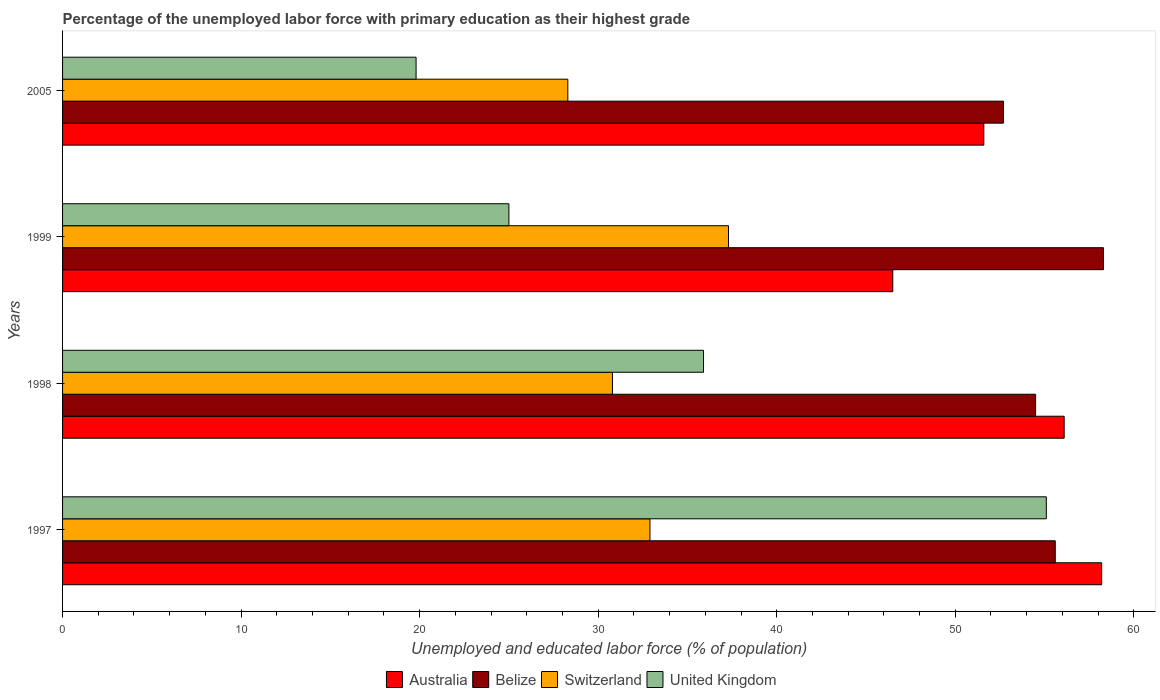How many different coloured bars are there?
Give a very brief answer. 4. How many groups of bars are there?
Your answer should be very brief. 4. Are the number of bars per tick equal to the number of legend labels?
Offer a very short reply. Yes. Are the number of bars on each tick of the Y-axis equal?
Ensure brevity in your answer.  Yes. How many bars are there on the 2nd tick from the bottom?
Offer a very short reply. 4. What is the percentage of the unemployed labor force with primary education in Belize in 1998?
Your answer should be very brief. 54.5. Across all years, what is the maximum percentage of the unemployed labor force with primary education in United Kingdom?
Ensure brevity in your answer.  55.1. Across all years, what is the minimum percentage of the unemployed labor force with primary education in Australia?
Keep it short and to the point. 46.5. In which year was the percentage of the unemployed labor force with primary education in United Kingdom maximum?
Keep it short and to the point. 1997. What is the total percentage of the unemployed labor force with primary education in Switzerland in the graph?
Make the answer very short. 129.3. What is the difference between the percentage of the unemployed labor force with primary education in Belize in 1997 and that in 2005?
Provide a succinct answer. 2.9. What is the difference between the percentage of the unemployed labor force with primary education in Belize in 1998 and the percentage of the unemployed labor force with primary education in United Kingdom in 1999?
Keep it short and to the point. 29.5. What is the average percentage of the unemployed labor force with primary education in Australia per year?
Make the answer very short. 53.1. In the year 1997, what is the difference between the percentage of the unemployed labor force with primary education in United Kingdom and percentage of the unemployed labor force with primary education in Belize?
Your answer should be very brief. -0.5. What is the ratio of the percentage of the unemployed labor force with primary education in Switzerland in 1998 to that in 1999?
Your answer should be very brief. 0.83. What is the difference between the highest and the second highest percentage of the unemployed labor force with primary education in Belize?
Keep it short and to the point. 2.7. What is the difference between the highest and the lowest percentage of the unemployed labor force with primary education in Belize?
Your answer should be compact. 5.6. Is the sum of the percentage of the unemployed labor force with primary education in Switzerland in 1999 and 2005 greater than the maximum percentage of the unemployed labor force with primary education in Australia across all years?
Offer a very short reply. Yes. Is it the case that in every year, the sum of the percentage of the unemployed labor force with primary education in United Kingdom and percentage of the unemployed labor force with primary education in Australia is greater than the sum of percentage of the unemployed labor force with primary education in Belize and percentage of the unemployed labor force with primary education in Switzerland?
Your answer should be compact. No. What does the 2nd bar from the top in 1999 represents?
Your answer should be compact. Switzerland. How many bars are there?
Offer a terse response. 16. Are all the bars in the graph horizontal?
Offer a terse response. Yes. How many years are there in the graph?
Your answer should be compact. 4. Are the values on the major ticks of X-axis written in scientific E-notation?
Your answer should be compact. No. What is the title of the graph?
Ensure brevity in your answer.  Percentage of the unemployed labor force with primary education as their highest grade. Does "Channel Islands" appear as one of the legend labels in the graph?
Your response must be concise. No. What is the label or title of the X-axis?
Provide a short and direct response. Unemployed and educated labor force (% of population). What is the Unemployed and educated labor force (% of population) in Australia in 1997?
Your response must be concise. 58.2. What is the Unemployed and educated labor force (% of population) in Belize in 1997?
Make the answer very short. 55.6. What is the Unemployed and educated labor force (% of population) in Switzerland in 1997?
Provide a succinct answer. 32.9. What is the Unemployed and educated labor force (% of population) of United Kingdom in 1997?
Your answer should be compact. 55.1. What is the Unemployed and educated labor force (% of population) of Australia in 1998?
Ensure brevity in your answer.  56.1. What is the Unemployed and educated labor force (% of population) of Belize in 1998?
Provide a succinct answer. 54.5. What is the Unemployed and educated labor force (% of population) in Switzerland in 1998?
Provide a short and direct response. 30.8. What is the Unemployed and educated labor force (% of population) in United Kingdom in 1998?
Keep it short and to the point. 35.9. What is the Unemployed and educated labor force (% of population) of Australia in 1999?
Give a very brief answer. 46.5. What is the Unemployed and educated labor force (% of population) of Belize in 1999?
Give a very brief answer. 58.3. What is the Unemployed and educated labor force (% of population) in Switzerland in 1999?
Your answer should be compact. 37.3. What is the Unemployed and educated labor force (% of population) in Australia in 2005?
Give a very brief answer. 51.6. What is the Unemployed and educated labor force (% of population) in Belize in 2005?
Give a very brief answer. 52.7. What is the Unemployed and educated labor force (% of population) of Switzerland in 2005?
Keep it short and to the point. 28.3. What is the Unemployed and educated labor force (% of population) of United Kingdom in 2005?
Your response must be concise. 19.8. Across all years, what is the maximum Unemployed and educated labor force (% of population) of Australia?
Provide a short and direct response. 58.2. Across all years, what is the maximum Unemployed and educated labor force (% of population) in Belize?
Keep it short and to the point. 58.3. Across all years, what is the maximum Unemployed and educated labor force (% of population) in Switzerland?
Keep it short and to the point. 37.3. Across all years, what is the maximum Unemployed and educated labor force (% of population) of United Kingdom?
Your response must be concise. 55.1. Across all years, what is the minimum Unemployed and educated labor force (% of population) of Australia?
Keep it short and to the point. 46.5. Across all years, what is the minimum Unemployed and educated labor force (% of population) of Belize?
Keep it short and to the point. 52.7. Across all years, what is the minimum Unemployed and educated labor force (% of population) of Switzerland?
Make the answer very short. 28.3. Across all years, what is the minimum Unemployed and educated labor force (% of population) in United Kingdom?
Make the answer very short. 19.8. What is the total Unemployed and educated labor force (% of population) in Australia in the graph?
Give a very brief answer. 212.4. What is the total Unemployed and educated labor force (% of population) of Belize in the graph?
Keep it short and to the point. 221.1. What is the total Unemployed and educated labor force (% of population) of Switzerland in the graph?
Provide a succinct answer. 129.3. What is the total Unemployed and educated labor force (% of population) in United Kingdom in the graph?
Offer a very short reply. 135.8. What is the difference between the Unemployed and educated labor force (% of population) in Switzerland in 1997 and that in 1998?
Provide a short and direct response. 2.1. What is the difference between the Unemployed and educated labor force (% of population) in United Kingdom in 1997 and that in 1998?
Your response must be concise. 19.2. What is the difference between the Unemployed and educated labor force (% of population) of Belize in 1997 and that in 1999?
Ensure brevity in your answer.  -2.7. What is the difference between the Unemployed and educated labor force (% of population) in United Kingdom in 1997 and that in 1999?
Make the answer very short. 30.1. What is the difference between the Unemployed and educated labor force (% of population) in Belize in 1997 and that in 2005?
Provide a succinct answer. 2.9. What is the difference between the Unemployed and educated labor force (% of population) of Switzerland in 1997 and that in 2005?
Your answer should be very brief. 4.6. What is the difference between the Unemployed and educated labor force (% of population) of United Kingdom in 1997 and that in 2005?
Your answer should be compact. 35.3. What is the difference between the Unemployed and educated labor force (% of population) of Belize in 1998 and that in 1999?
Provide a short and direct response. -3.8. What is the difference between the Unemployed and educated labor force (% of population) of Australia in 1998 and that in 2005?
Ensure brevity in your answer.  4.5. What is the difference between the Unemployed and educated labor force (% of population) of Belize in 1998 and that in 2005?
Make the answer very short. 1.8. What is the difference between the Unemployed and educated labor force (% of population) of Switzerland in 1998 and that in 2005?
Make the answer very short. 2.5. What is the difference between the Unemployed and educated labor force (% of population) of United Kingdom in 1998 and that in 2005?
Give a very brief answer. 16.1. What is the difference between the Unemployed and educated labor force (% of population) of Australia in 1997 and the Unemployed and educated labor force (% of population) of Switzerland in 1998?
Your response must be concise. 27.4. What is the difference between the Unemployed and educated labor force (% of population) of Australia in 1997 and the Unemployed and educated labor force (% of population) of United Kingdom in 1998?
Ensure brevity in your answer.  22.3. What is the difference between the Unemployed and educated labor force (% of population) in Belize in 1997 and the Unemployed and educated labor force (% of population) in Switzerland in 1998?
Provide a short and direct response. 24.8. What is the difference between the Unemployed and educated labor force (% of population) of Belize in 1997 and the Unemployed and educated labor force (% of population) of United Kingdom in 1998?
Your answer should be very brief. 19.7. What is the difference between the Unemployed and educated labor force (% of population) of Switzerland in 1997 and the Unemployed and educated labor force (% of population) of United Kingdom in 1998?
Your response must be concise. -3. What is the difference between the Unemployed and educated labor force (% of population) in Australia in 1997 and the Unemployed and educated labor force (% of population) in Belize in 1999?
Make the answer very short. -0.1. What is the difference between the Unemployed and educated labor force (% of population) of Australia in 1997 and the Unemployed and educated labor force (% of population) of Switzerland in 1999?
Give a very brief answer. 20.9. What is the difference between the Unemployed and educated labor force (% of population) in Australia in 1997 and the Unemployed and educated labor force (% of population) in United Kingdom in 1999?
Ensure brevity in your answer.  33.2. What is the difference between the Unemployed and educated labor force (% of population) of Belize in 1997 and the Unemployed and educated labor force (% of population) of Switzerland in 1999?
Keep it short and to the point. 18.3. What is the difference between the Unemployed and educated labor force (% of population) of Belize in 1997 and the Unemployed and educated labor force (% of population) of United Kingdom in 1999?
Your answer should be compact. 30.6. What is the difference between the Unemployed and educated labor force (% of population) in Switzerland in 1997 and the Unemployed and educated labor force (% of population) in United Kingdom in 1999?
Your answer should be very brief. 7.9. What is the difference between the Unemployed and educated labor force (% of population) in Australia in 1997 and the Unemployed and educated labor force (% of population) in Switzerland in 2005?
Ensure brevity in your answer.  29.9. What is the difference between the Unemployed and educated labor force (% of population) in Australia in 1997 and the Unemployed and educated labor force (% of population) in United Kingdom in 2005?
Your answer should be very brief. 38.4. What is the difference between the Unemployed and educated labor force (% of population) in Belize in 1997 and the Unemployed and educated labor force (% of population) in Switzerland in 2005?
Make the answer very short. 27.3. What is the difference between the Unemployed and educated labor force (% of population) in Belize in 1997 and the Unemployed and educated labor force (% of population) in United Kingdom in 2005?
Provide a short and direct response. 35.8. What is the difference between the Unemployed and educated labor force (% of population) in Switzerland in 1997 and the Unemployed and educated labor force (% of population) in United Kingdom in 2005?
Your answer should be compact. 13.1. What is the difference between the Unemployed and educated labor force (% of population) of Australia in 1998 and the Unemployed and educated labor force (% of population) of United Kingdom in 1999?
Your answer should be compact. 31.1. What is the difference between the Unemployed and educated labor force (% of population) in Belize in 1998 and the Unemployed and educated labor force (% of population) in Switzerland in 1999?
Your response must be concise. 17.2. What is the difference between the Unemployed and educated labor force (% of population) in Belize in 1998 and the Unemployed and educated labor force (% of population) in United Kingdom in 1999?
Provide a succinct answer. 29.5. What is the difference between the Unemployed and educated labor force (% of population) of Australia in 1998 and the Unemployed and educated labor force (% of population) of Belize in 2005?
Make the answer very short. 3.4. What is the difference between the Unemployed and educated labor force (% of population) in Australia in 1998 and the Unemployed and educated labor force (% of population) in Switzerland in 2005?
Give a very brief answer. 27.8. What is the difference between the Unemployed and educated labor force (% of population) in Australia in 1998 and the Unemployed and educated labor force (% of population) in United Kingdom in 2005?
Provide a short and direct response. 36.3. What is the difference between the Unemployed and educated labor force (% of population) in Belize in 1998 and the Unemployed and educated labor force (% of population) in Switzerland in 2005?
Your answer should be compact. 26.2. What is the difference between the Unemployed and educated labor force (% of population) of Belize in 1998 and the Unemployed and educated labor force (% of population) of United Kingdom in 2005?
Your answer should be compact. 34.7. What is the difference between the Unemployed and educated labor force (% of population) in Switzerland in 1998 and the Unemployed and educated labor force (% of population) in United Kingdom in 2005?
Provide a short and direct response. 11. What is the difference between the Unemployed and educated labor force (% of population) in Australia in 1999 and the Unemployed and educated labor force (% of population) in Belize in 2005?
Make the answer very short. -6.2. What is the difference between the Unemployed and educated labor force (% of population) in Australia in 1999 and the Unemployed and educated labor force (% of population) in United Kingdom in 2005?
Offer a terse response. 26.7. What is the difference between the Unemployed and educated labor force (% of population) of Belize in 1999 and the Unemployed and educated labor force (% of population) of Switzerland in 2005?
Offer a very short reply. 30. What is the difference between the Unemployed and educated labor force (% of population) in Belize in 1999 and the Unemployed and educated labor force (% of population) in United Kingdom in 2005?
Offer a very short reply. 38.5. What is the difference between the Unemployed and educated labor force (% of population) in Switzerland in 1999 and the Unemployed and educated labor force (% of population) in United Kingdom in 2005?
Offer a terse response. 17.5. What is the average Unemployed and educated labor force (% of population) of Australia per year?
Offer a terse response. 53.1. What is the average Unemployed and educated labor force (% of population) of Belize per year?
Offer a very short reply. 55.27. What is the average Unemployed and educated labor force (% of population) in Switzerland per year?
Offer a terse response. 32.33. What is the average Unemployed and educated labor force (% of population) in United Kingdom per year?
Your answer should be very brief. 33.95. In the year 1997, what is the difference between the Unemployed and educated labor force (% of population) of Australia and Unemployed and educated labor force (% of population) of Belize?
Provide a succinct answer. 2.6. In the year 1997, what is the difference between the Unemployed and educated labor force (% of population) of Australia and Unemployed and educated labor force (% of population) of Switzerland?
Your response must be concise. 25.3. In the year 1997, what is the difference between the Unemployed and educated labor force (% of population) of Belize and Unemployed and educated labor force (% of population) of Switzerland?
Make the answer very short. 22.7. In the year 1997, what is the difference between the Unemployed and educated labor force (% of population) of Belize and Unemployed and educated labor force (% of population) of United Kingdom?
Make the answer very short. 0.5. In the year 1997, what is the difference between the Unemployed and educated labor force (% of population) in Switzerland and Unemployed and educated labor force (% of population) in United Kingdom?
Your response must be concise. -22.2. In the year 1998, what is the difference between the Unemployed and educated labor force (% of population) of Australia and Unemployed and educated labor force (% of population) of Switzerland?
Offer a terse response. 25.3. In the year 1998, what is the difference between the Unemployed and educated labor force (% of population) of Australia and Unemployed and educated labor force (% of population) of United Kingdom?
Keep it short and to the point. 20.2. In the year 1998, what is the difference between the Unemployed and educated labor force (% of population) in Belize and Unemployed and educated labor force (% of population) in Switzerland?
Your answer should be compact. 23.7. In the year 1998, what is the difference between the Unemployed and educated labor force (% of population) in Belize and Unemployed and educated labor force (% of population) in United Kingdom?
Your response must be concise. 18.6. In the year 1998, what is the difference between the Unemployed and educated labor force (% of population) of Switzerland and Unemployed and educated labor force (% of population) of United Kingdom?
Provide a short and direct response. -5.1. In the year 1999, what is the difference between the Unemployed and educated labor force (% of population) of Australia and Unemployed and educated labor force (% of population) of Switzerland?
Ensure brevity in your answer.  9.2. In the year 1999, what is the difference between the Unemployed and educated labor force (% of population) of Australia and Unemployed and educated labor force (% of population) of United Kingdom?
Make the answer very short. 21.5. In the year 1999, what is the difference between the Unemployed and educated labor force (% of population) in Belize and Unemployed and educated labor force (% of population) in Switzerland?
Ensure brevity in your answer.  21. In the year 1999, what is the difference between the Unemployed and educated labor force (% of population) in Belize and Unemployed and educated labor force (% of population) in United Kingdom?
Provide a succinct answer. 33.3. In the year 1999, what is the difference between the Unemployed and educated labor force (% of population) in Switzerland and Unemployed and educated labor force (% of population) in United Kingdom?
Offer a terse response. 12.3. In the year 2005, what is the difference between the Unemployed and educated labor force (% of population) of Australia and Unemployed and educated labor force (% of population) of Switzerland?
Provide a short and direct response. 23.3. In the year 2005, what is the difference between the Unemployed and educated labor force (% of population) of Australia and Unemployed and educated labor force (% of population) of United Kingdom?
Give a very brief answer. 31.8. In the year 2005, what is the difference between the Unemployed and educated labor force (% of population) in Belize and Unemployed and educated labor force (% of population) in Switzerland?
Offer a very short reply. 24.4. In the year 2005, what is the difference between the Unemployed and educated labor force (% of population) in Belize and Unemployed and educated labor force (% of population) in United Kingdom?
Make the answer very short. 32.9. In the year 2005, what is the difference between the Unemployed and educated labor force (% of population) in Switzerland and Unemployed and educated labor force (% of population) in United Kingdom?
Your answer should be compact. 8.5. What is the ratio of the Unemployed and educated labor force (% of population) of Australia in 1997 to that in 1998?
Your answer should be compact. 1.04. What is the ratio of the Unemployed and educated labor force (% of population) in Belize in 1997 to that in 1998?
Ensure brevity in your answer.  1.02. What is the ratio of the Unemployed and educated labor force (% of population) of Switzerland in 1997 to that in 1998?
Offer a very short reply. 1.07. What is the ratio of the Unemployed and educated labor force (% of population) of United Kingdom in 1997 to that in 1998?
Provide a short and direct response. 1.53. What is the ratio of the Unemployed and educated labor force (% of population) in Australia in 1997 to that in 1999?
Your response must be concise. 1.25. What is the ratio of the Unemployed and educated labor force (% of population) of Belize in 1997 to that in 1999?
Give a very brief answer. 0.95. What is the ratio of the Unemployed and educated labor force (% of population) of Switzerland in 1997 to that in 1999?
Offer a terse response. 0.88. What is the ratio of the Unemployed and educated labor force (% of population) of United Kingdom in 1997 to that in 1999?
Your response must be concise. 2.2. What is the ratio of the Unemployed and educated labor force (% of population) in Australia in 1997 to that in 2005?
Provide a succinct answer. 1.13. What is the ratio of the Unemployed and educated labor force (% of population) in Belize in 1997 to that in 2005?
Make the answer very short. 1.05. What is the ratio of the Unemployed and educated labor force (% of population) of Switzerland in 1997 to that in 2005?
Offer a very short reply. 1.16. What is the ratio of the Unemployed and educated labor force (% of population) in United Kingdom in 1997 to that in 2005?
Give a very brief answer. 2.78. What is the ratio of the Unemployed and educated labor force (% of population) in Australia in 1998 to that in 1999?
Ensure brevity in your answer.  1.21. What is the ratio of the Unemployed and educated labor force (% of population) in Belize in 1998 to that in 1999?
Make the answer very short. 0.93. What is the ratio of the Unemployed and educated labor force (% of population) of Switzerland in 1998 to that in 1999?
Keep it short and to the point. 0.83. What is the ratio of the Unemployed and educated labor force (% of population) in United Kingdom in 1998 to that in 1999?
Make the answer very short. 1.44. What is the ratio of the Unemployed and educated labor force (% of population) of Australia in 1998 to that in 2005?
Ensure brevity in your answer.  1.09. What is the ratio of the Unemployed and educated labor force (% of population) of Belize in 1998 to that in 2005?
Give a very brief answer. 1.03. What is the ratio of the Unemployed and educated labor force (% of population) of Switzerland in 1998 to that in 2005?
Offer a terse response. 1.09. What is the ratio of the Unemployed and educated labor force (% of population) of United Kingdom in 1998 to that in 2005?
Give a very brief answer. 1.81. What is the ratio of the Unemployed and educated labor force (% of population) in Australia in 1999 to that in 2005?
Provide a succinct answer. 0.9. What is the ratio of the Unemployed and educated labor force (% of population) of Belize in 1999 to that in 2005?
Offer a terse response. 1.11. What is the ratio of the Unemployed and educated labor force (% of population) in Switzerland in 1999 to that in 2005?
Keep it short and to the point. 1.32. What is the ratio of the Unemployed and educated labor force (% of population) in United Kingdom in 1999 to that in 2005?
Your answer should be compact. 1.26. What is the difference between the highest and the second highest Unemployed and educated labor force (% of population) of Belize?
Your response must be concise. 2.7. What is the difference between the highest and the second highest Unemployed and educated labor force (% of population) of Switzerland?
Ensure brevity in your answer.  4.4. What is the difference between the highest and the second highest Unemployed and educated labor force (% of population) in United Kingdom?
Ensure brevity in your answer.  19.2. What is the difference between the highest and the lowest Unemployed and educated labor force (% of population) in Switzerland?
Provide a succinct answer. 9. What is the difference between the highest and the lowest Unemployed and educated labor force (% of population) in United Kingdom?
Your answer should be compact. 35.3. 